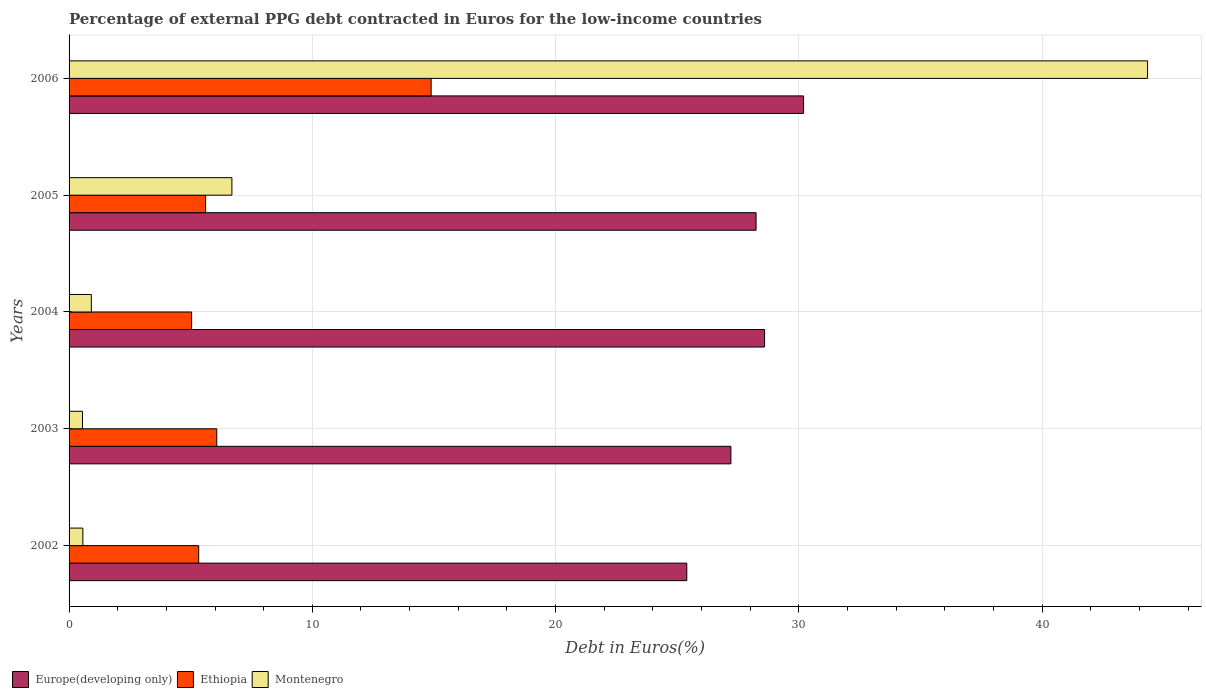How many groups of bars are there?
Make the answer very short. 5. Are the number of bars on each tick of the Y-axis equal?
Your response must be concise. Yes. How many bars are there on the 2nd tick from the bottom?
Provide a succinct answer. 3. What is the label of the 1st group of bars from the top?
Ensure brevity in your answer.  2006. In how many cases, is the number of bars for a given year not equal to the number of legend labels?
Offer a terse response. 0. What is the percentage of external PPG debt contracted in Euros in Europe(developing only) in 2005?
Your answer should be compact. 28.24. Across all years, what is the maximum percentage of external PPG debt contracted in Euros in Ethiopia?
Provide a short and direct response. 14.88. Across all years, what is the minimum percentage of external PPG debt contracted in Euros in Ethiopia?
Make the answer very short. 5.04. In which year was the percentage of external PPG debt contracted in Euros in Ethiopia maximum?
Ensure brevity in your answer.  2006. What is the total percentage of external PPG debt contracted in Euros in Montenegro in the graph?
Offer a very short reply. 53.06. What is the difference between the percentage of external PPG debt contracted in Euros in Montenegro in 2003 and that in 2006?
Make the answer very short. -43.78. What is the difference between the percentage of external PPG debt contracted in Euros in Europe(developing only) in 2005 and the percentage of external PPG debt contracted in Euros in Ethiopia in 2003?
Make the answer very short. 22.17. What is the average percentage of external PPG debt contracted in Euros in Europe(developing only) per year?
Keep it short and to the point. 27.93. In the year 2003, what is the difference between the percentage of external PPG debt contracted in Euros in Montenegro and percentage of external PPG debt contracted in Euros in Ethiopia?
Ensure brevity in your answer.  -5.52. What is the ratio of the percentage of external PPG debt contracted in Euros in Europe(developing only) in 2005 to that in 2006?
Provide a short and direct response. 0.94. Is the percentage of external PPG debt contracted in Euros in Ethiopia in 2002 less than that in 2003?
Provide a short and direct response. Yes. Is the difference between the percentage of external PPG debt contracted in Euros in Montenegro in 2002 and 2005 greater than the difference between the percentage of external PPG debt contracted in Euros in Ethiopia in 2002 and 2005?
Make the answer very short. No. What is the difference between the highest and the second highest percentage of external PPG debt contracted in Euros in Ethiopia?
Provide a succinct answer. 8.81. What is the difference between the highest and the lowest percentage of external PPG debt contracted in Euros in Montenegro?
Your answer should be compact. 43.78. What does the 2nd bar from the top in 2004 represents?
Make the answer very short. Ethiopia. What does the 1st bar from the bottom in 2005 represents?
Make the answer very short. Europe(developing only). How many years are there in the graph?
Keep it short and to the point. 5. What is the difference between two consecutive major ticks on the X-axis?
Your answer should be very brief. 10. Are the values on the major ticks of X-axis written in scientific E-notation?
Your answer should be compact. No. Where does the legend appear in the graph?
Provide a short and direct response. Bottom left. What is the title of the graph?
Provide a succinct answer. Percentage of external PPG debt contracted in Euros for the low-income countries. Does "Palau" appear as one of the legend labels in the graph?
Your response must be concise. No. What is the label or title of the X-axis?
Keep it short and to the point. Debt in Euros(%). What is the label or title of the Y-axis?
Give a very brief answer. Years. What is the Debt in Euros(%) of Europe(developing only) in 2002?
Keep it short and to the point. 25.39. What is the Debt in Euros(%) in Ethiopia in 2002?
Give a very brief answer. 5.33. What is the Debt in Euros(%) of Montenegro in 2002?
Your answer should be very brief. 0.57. What is the Debt in Euros(%) of Europe(developing only) in 2003?
Offer a terse response. 27.21. What is the Debt in Euros(%) in Ethiopia in 2003?
Keep it short and to the point. 6.07. What is the Debt in Euros(%) of Montenegro in 2003?
Give a very brief answer. 0.55. What is the Debt in Euros(%) of Europe(developing only) in 2004?
Provide a short and direct response. 28.59. What is the Debt in Euros(%) of Ethiopia in 2004?
Offer a very short reply. 5.04. What is the Debt in Euros(%) of Montenegro in 2004?
Your response must be concise. 0.92. What is the Debt in Euros(%) in Europe(developing only) in 2005?
Provide a succinct answer. 28.24. What is the Debt in Euros(%) in Ethiopia in 2005?
Your response must be concise. 5.61. What is the Debt in Euros(%) of Montenegro in 2005?
Provide a short and direct response. 6.69. What is the Debt in Euros(%) of Europe(developing only) in 2006?
Provide a short and direct response. 30.19. What is the Debt in Euros(%) of Ethiopia in 2006?
Make the answer very short. 14.88. What is the Debt in Euros(%) in Montenegro in 2006?
Keep it short and to the point. 44.34. Across all years, what is the maximum Debt in Euros(%) in Europe(developing only)?
Your answer should be compact. 30.19. Across all years, what is the maximum Debt in Euros(%) of Ethiopia?
Offer a very short reply. 14.88. Across all years, what is the maximum Debt in Euros(%) of Montenegro?
Make the answer very short. 44.34. Across all years, what is the minimum Debt in Euros(%) of Europe(developing only)?
Offer a terse response. 25.39. Across all years, what is the minimum Debt in Euros(%) in Ethiopia?
Your answer should be compact. 5.04. Across all years, what is the minimum Debt in Euros(%) of Montenegro?
Ensure brevity in your answer.  0.55. What is the total Debt in Euros(%) of Europe(developing only) in the graph?
Your answer should be compact. 139.63. What is the total Debt in Euros(%) in Ethiopia in the graph?
Provide a succinct answer. 36.93. What is the total Debt in Euros(%) in Montenegro in the graph?
Offer a terse response. 53.06. What is the difference between the Debt in Euros(%) in Europe(developing only) in 2002 and that in 2003?
Make the answer very short. -1.81. What is the difference between the Debt in Euros(%) of Ethiopia in 2002 and that in 2003?
Make the answer very short. -0.74. What is the difference between the Debt in Euros(%) of Montenegro in 2002 and that in 2003?
Your answer should be compact. 0.01. What is the difference between the Debt in Euros(%) in Europe(developing only) in 2002 and that in 2004?
Give a very brief answer. -3.2. What is the difference between the Debt in Euros(%) in Ethiopia in 2002 and that in 2004?
Keep it short and to the point. 0.29. What is the difference between the Debt in Euros(%) in Montenegro in 2002 and that in 2004?
Offer a terse response. -0.35. What is the difference between the Debt in Euros(%) of Europe(developing only) in 2002 and that in 2005?
Your answer should be compact. -2.85. What is the difference between the Debt in Euros(%) in Ethiopia in 2002 and that in 2005?
Keep it short and to the point. -0.28. What is the difference between the Debt in Euros(%) of Montenegro in 2002 and that in 2005?
Offer a terse response. -6.13. What is the difference between the Debt in Euros(%) of Europe(developing only) in 2002 and that in 2006?
Provide a succinct answer. -4.8. What is the difference between the Debt in Euros(%) in Ethiopia in 2002 and that in 2006?
Your response must be concise. -9.56. What is the difference between the Debt in Euros(%) of Montenegro in 2002 and that in 2006?
Ensure brevity in your answer.  -43.77. What is the difference between the Debt in Euros(%) in Europe(developing only) in 2003 and that in 2004?
Your response must be concise. -1.38. What is the difference between the Debt in Euros(%) in Ethiopia in 2003 and that in 2004?
Your answer should be compact. 1.03. What is the difference between the Debt in Euros(%) in Montenegro in 2003 and that in 2004?
Your response must be concise. -0.36. What is the difference between the Debt in Euros(%) in Europe(developing only) in 2003 and that in 2005?
Provide a succinct answer. -1.03. What is the difference between the Debt in Euros(%) in Ethiopia in 2003 and that in 2005?
Provide a short and direct response. 0.46. What is the difference between the Debt in Euros(%) of Montenegro in 2003 and that in 2005?
Offer a terse response. -6.14. What is the difference between the Debt in Euros(%) of Europe(developing only) in 2003 and that in 2006?
Give a very brief answer. -2.99. What is the difference between the Debt in Euros(%) of Ethiopia in 2003 and that in 2006?
Ensure brevity in your answer.  -8.81. What is the difference between the Debt in Euros(%) of Montenegro in 2003 and that in 2006?
Your answer should be compact. -43.78. What is the difference between the Debt in Euros(%) in Europe(developing only) in 2004 and that in 2005?
Offer a terse response. 0.35. What is the difference between the Debt in Euros(%) in Ethiopia in 2004 and that in 2005?
Ensure brevity in your answer.  -0.57. What is the difference between the Debt in Euros(%) of Montenegro in 2004 and that in 2005?
Make the answer very short. -5.78. What is the difference between the Debt in Euros(%) of Europe(developing only) in 2004 and that in 2006?
Your response must be concise. -1.6. What is the difference between the Debt in Euros(%) of Ethiopia in 2004 and that in 2006?
Ensure brevity in your answer.  -9.85. What is the difference between the Debt in Euros(%) in Montenegro in 2004 and that in 2006?
Give a very brief answer. -43.42. What is the difference between the Debt in Euros(%) of Europe(developing only) in 2005 and that in 2006?
Ensure brevity in your answer.  -1.95. What is the difference between the Debt in Euros(%) in Ethiopia in 2005 and that in 2006?
Your response must be concise. -9.27. What is the difference between the Debt in Euros(%) of Montenegro in 2005 and that in 2006?
Your answer should be very brief. -37.64. What is the difference between the Debt in Euros(%) of Europe(developing only) in 2002 and the Debt in Euros(%) of Ethiopia in 2003?
Keep it short and to the point. 19.32. What is the difference between the Debt in Euros(%) of Europe(developing only) in 2002 and the Debt in Euros(%) of Montenegro in 2003?
Ensure brevity in your answer.  24.84. What is the difference between the Debt in Euros(%) in Ethiopia in 2002 and the Debt in Euros(%) in Montenegro in 2003?
Keep it short and to the point. 4.78. What is the difference between the Debt in Euros(%) in Europe(developing only) in 2002 and the Debt in Euros(%) in Ethiopia in 2004?
Make the answer very short. 20.36. What is the difference between the Debt in Euros(%) in Europe(developing only) in 2002 and the Debt in Euros(%) in Montenegro in 2004?
Provide a succinct answer. 24.48. What is the difference between the Debt in Euros(%) in Ethiopia in 2002 and the Debt in Euros(%) in Montenegro in 2004?
Provide a succinct answer. 4.41. What is the difference between the Debt in Euros(%) in Europe(developing only) in 2002 and the Debt in Euros(%) in Ethiopia in 2005?
Provide a short and direct response. 19.78. What is the difference between the Debt in Euros(%) in Europe(developing only) in 2002 and the Debt in Euros(%) in Montenegro in 2005?
Your answer should be compact. 18.7. What is the difference between the Debt in Euros(%) in Ethiopia in 2002 and the Debt in Euros(%) in Montenegro in 2005?
Your response must be concise. -1.37. What is the difference between the Debt in Euros(%) of Europe(developing only) in 2002 and the Debt in Euros(%) of Ethiopia in 2006?
Keep it short and to the point. 10.51. What is the difference between the Debt in Euros(%) of Europe(developing only) in 2002 and the Debt in Euros(%) of Montenegro in 2006?
Ensure brevity in your answer.  -18.94. What is the difference between the Debt in Euros(%) in Ethiopia in 2002 and the Debt in Euros(%) in Montenegro in 2006?
Your answer should be very brief. -39.01. What is the difference between the Debt in Euros(%) of Europe(developing only) in 2003 and the Debt in Euros(%) of Ethiopia in 2004?
Give a very brief answer. 22.17. What is the difference between the Debt in Euros(%) in Europe(developing only) in 2003 and the Debt in Euros(%) in Montenegro in 2004?
Your answer should be very brief. 26.29. What is the difference between the Debt in Euros(%) in Ethiopia in 2003 and the Debt in Euros(%) in Montenegro in 2004?
Offer a very short reply. 5.16. What is the difference between the Debt in Euros(%) in Europe(developing only) in 2003 and the Debt in Euros(%) in Ethiopia in 2005?
Keep it short and to the point. 21.6. What is the difference between the Debt in Euros(%) of Europe(developing only) in 2003 and the Debt in Euros(%) of Montenegro in 2005?
Your answer should be compact. 20.51. What is the difference between the Debt in Euros(%) in Ethiopia in 2003 and the Debt in Euros(%) in Montenegro in 2005?
Provide a short and direct response. -0.62. What is the difference between the Debt in Euros(%) of Europe(developing only) in 2003 and the Debt in Euros(%) of Ethiopia in 2006?
Your answer should be very brief. 12.32. What is the difference between the Debt in Euros(%) in Europe(developing only) in 2003 and the Debt in Euros(%) in Montenegro in 2006?
Provide a short and direct response. -17.13. What is the difference between the Debt in Euros(%) in Ethiopia in 2003 and the Debt in Euros(%) in Montenegro in 2006?
Your answer should be compact. -38.26. What is the difference between the Debt in Euros(%) of Europe(developing only) in 2004 and the Debt in Euros(%) of Ethiopia in 2005?
Offer a very short reply. 22.98. What is the difference between the Debt in Euros(%) in Europe(developing only) in 2004 and the Debt in Euros(%) in Montenegro in 2005?
Your response must be concise. 21.9. What is the difference between the Debt in Euros(%) of Ethiopia in 2004 and the Debt in Euros(%) of Montenegro in 2005?
Provide a short and direct response. -1.66. What is the difference between the Debt in Euros(%) of Europe(developing only) in 2004 and the Debt in Euros(%) of Ethiopia in 2006?
Make the answer very short. 13.71. What is the difference between the Debt in Euros(%) of Europe(developing only) in 2004 and the Debt in Euros(%) of Montenegro in 2006?
Your response must be concise. -15.74. What is the difference between the Debt in Euros(%) of Ethiopia in 2004 and the Debt in Euros(%) of Montenegro in 2006?
Provide a short and direct response. -39.3. What is the difference between the Debt in Euros(%) of Europe(developing only) in 2005 and the Debt in Euros(%) of Ethiopia in 2006?
Give a very brief answer. 13.36. What is the difference between the Debt in Euros(%) in Europe(developing only) in 2005 and the Debt in Euros(%) in Montenegro in 2006?
Your answer should be very brief. -16.09. What is the difference between the Debt in Euros(%) in Ethiopia in 2005 and the Debt in Euros(%) in Montenegro in 2006?
Give a very brief answer. -38.72. What is the average Debt in Euros(%) in Europe(developing only) per year?
Your answer should be compact. 27.93. What is the average Debt in Euros(%) of Ethiopia per year?
Make the answer very short. 7.39. What is the average Debt in Euros(%) of Montenegro per year?
Provide a short and direct response. 10.61. In the year 2002, what is the difference between the Debt in Euros(%) of Europe(developing only) and Debt in Euros(%) of Ethiopia?
Your answer should be very brief. 20.06. In the year 2002, what is the difference between the Debt in Euros(%) of Europe(developing only) and Debt in Euros(%) of Montenegro?
Provide a succinct answer. 24.83. In the year 2002, what is the difference between the Debt in Euros(%) in Ethiopia and Debt in Euros(%) in Montenegro?
Offer a terse response. 4.76. In the year 2003, what is the difference between the Debt in Euros(%) of Europe(developing only) and Debt in Euros(%) of Ethiopia?
Give a very brief answer. 21.14. In the year 2003, what is the difference between the Debt in Euros(%) in Europe(developing only) and Debt in Euros(%) in Montenegro?
Make the answer very short. 26.65. In the year 2003, what is the difference between the Debt in Euros(%) of Ethiopia and Debt in Euros(%) of Montenegro?
Offer a very short reply. 5.52. In the year 2004, what is the difference between the Debt in Euros(%) in Europe(developing only) and Debt in Euros(%) in Ethiopia?
Give a very brief answer. 23.55. In the year 2004, what is the difference between the Debt in Euros(%) in Europe(developing only) and Debt in Euros(%) in Montenegro?
Your answer should be very brief. 27.68. In the year 2004, what is the difference between the Debt in Euros(%) of Ethiopia and Debt in Euros(%) of Montenegro?
Your answer should be very brief. 4.12. In the year 2005, what is the difference between the Debt in Euros(%) in Europe(developing only) and Debt in Euros(%) in Ethiopia?
Provide a short and direct response. 22.63. In the year 2005, what is the difference between the Debt in Euros(%) in Europe(developing only) and Debt in Euros(%) in Montenegro?
Offer a very short reply. 21.55. In the year 2005, what is the difference between the Debt in Euros(%) of Ethiopia and Debt in Euros(%) of Montenegro?
Offer a very short reply. -1.08. In the year 2006, what is the difference between the Debt in Euros(%) of Europe(developing only) and Debt in Euros(%) of Ethiopia?
Give a very brief answer. 15.31. In the year 2006, what is the difference between the Debt in Euros(%) of Europe(developing only) and Debt in Euros(%) of Montenegro?
Ensure brevity in your answer.  -14.14. In the year 2006, what is the difference between the Debt in Euros(%) of Ethiopia and Debt in Euros(%) of Montenegro?
Make the answer very short. -29.45. What is the ratio of the Debt in Euros(%) of Ethiopia in 2002 to that in 2003?
Give a very brief answer. 0.88. What is the ratio of the Debt in Euros(%) in Montenegro in 2002 to that in 2003?
Give a very brief answer. 1.03. What is the ratio of the Debt in Euros(%) of Europe(developing only) in 2002 to that in 2004?
Make the answer very short. 0.89. What is the ratio of the Debt in Euros(%) of Ethiopia in 2002 to that in 2004?
Ensure brevity in your answer.  1.06. What is the ratio of the Debt in Euros(%) of Montenegro in 2002 to that in 2004?
Provide a short and direct response. 0.62. What is the ratio of the Debt in Euros(%) in Europe(developing only) in 2002 to that in 2005?
Offer a very short reply. 0.9. What is the ratio of the Debt in Euros(%) in Ethiopia in 2002 to that in 2005?
Your answer should be very brief. 0.95. What is the ratio of the Debt in Euros(%) of Montenegro in 2002 to that in 2005?
Ensure brevity in your answer.  0.08. What is the ratio of the Debt in Euros(%) of Europe(developing only) in 2002 to that in 2006?
Make the answer very short. 0.84. What is the ratio of the Debt in Euros(%) of Ethiopia in 2002 to that in 2006?
Provide a short and direct response. 0.36. What is the ratio of the Debt in Euros(%) in Montenegro in 2002 to that in 2006?
Your answer should be very brief. 0.01. What is the ratio of the Debt in Euros(%) in Europe(developing only) in 2003 to that in 2004?
Offer a terse response. 0.95. What is the ratio of the Debt in Euros(%) in Ethiopia in 2003 to that in 2004?
Your answer should be compact. 1.21. What is the ratio of the Debt in Euros(%) of Montenegro in 2003 to that in 2004?
Make the answer very short. 0.6. What is the ratio of the Debt in Euros(%) of Europe(developing only) in 2003 to that in 2005?
Your answer should be very brief. 0.96. What is the ratio of the Debt in Euros(%) of Ethiopia in 2003 to that in 2005?
Keep it short and to the point. 1.08. What is the ratio of the Debt in Euros(%) in Montenegro in 2003 to that in 2005?
Your response must be concise. 0.08. What is the ratio of the Debt in Euros(%) in Europe(developing only) in 2003 to that in 2006?
Provide a short and direct response. 0.9. What is the ratio of the Debt in Euros(%) in Ethiopia in 2003 to that in 2006?
Provide a succinct answer. 0.41. What is the ratio of the Debt in Euros(%) of Montenegro in 2003 to that in 2006?
Ensure brevity in your answer.  0.01. What is the ratio of the Debt in Euros(%) in Europe(developing only) in 2004 to that in 2005?
Offer a very short reply. 1.01. What is the ratio of the Debt in Euros(%) in Ethiopia in 2004 to that in 2005?
Give a very brief answer. 0.9. What is the ratio of the Debt in Euros(%) in Montenegro in 2004 to that in 2005?
Your response must be concise. 0.14. What is the ratio of the Debt in Euros(%) in Europe(developing only) in 2004 to that in 2006?
Your answer should be compact. 0.95. What is the ratio of the Debt in Euros(%) in Ethiopia in 2004 to that in 2006?
Keep it short and to the point. 0.34. What is the ratio of the Debt in Euros(%) in Montenegro in 2004 to that in 2006?
Your answer should be very brief. 0.02. What is the ratio of the Debt in Euros(%) of Europe(developing only) in 2005 to that in 2006?
Ensure brevity in your answer.  0.94. What is the ratio of the Debt in Euros(%) in Ethiopia in 2005 to that in 2006?
Your answer should be very brief. 0.38. What is the ratio of the Debt in Euros(%) in Montenegro in 2005 to that in 2006?
Keep it short and to the point. 0.15. What is the difference between the highest and the second highest Debt in Euros(%) in Europe(developing only)?
Give a very brief answer. 1.6. What is the difference between the highest and the second highest Debt in Euros(%) in Ethiopia?
Offer a very short reply. 8.81. What is the difference between the highest and the second highest Debt in Euros(%) in Montenegro?
Give a very brief answer. 37.64. What is the difference between the highest and the lowest Debt in Euros(%) in Europe(developing only)?
Your response must be concise. 4.8. What is the difference between the highest and the lowest Debt in Euros(%) in Ethiopia?
Your answer should be very brief. 9.85. What is the difference between the highest and the lowest Debt in Euros(%) in Montenegro?
Ensure brevity in your answer.  43.78. 